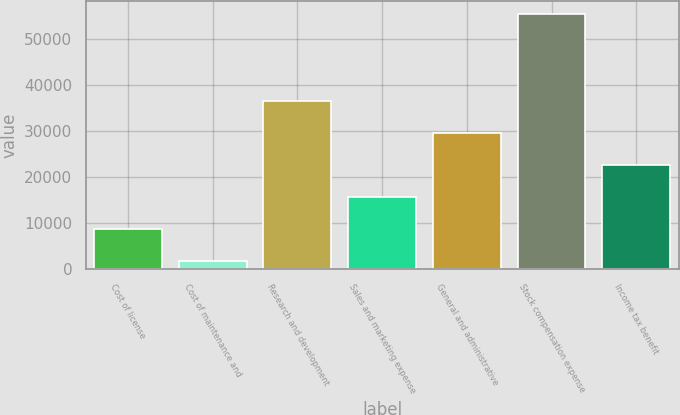Convert chart. <chart><loc_0><loc_0><loc_500><loc_500><bar_chart><fcel>Cost of license<fcel>Cost of maintenance and<fcel>Research and development<fcel>Sales and marketing expense<fcel>General and administrative<fcel>Stock compensation expense<fcel>Income tax benefit<nl><fcel>8695.7<fcel>1727<fcel>36570.5<fcel>15664.4<fcel>29601.8<fcel>55425<fcel>22633.1<nl></chart> 